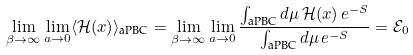<formula> <loc_0><loc_0><loc_500><loc_500>\lim _ { \beta \to \infty } \lim _ { a \to 0 } \langle \mathcal { H } ( x ) \rangle _ { \text {aPBC} } = \lim _ { \beta \to \infty } \lim _ { a \to 0 } \frac { \int _ { \text {aPBC} } d \mu \, \mathcal { H } ( x ) \, e ^ { - S } } { \int _ { \text {aPBC} } d \mu \, e ^ { - S } } = \mathcal { E } _ { 0 }</formula> 